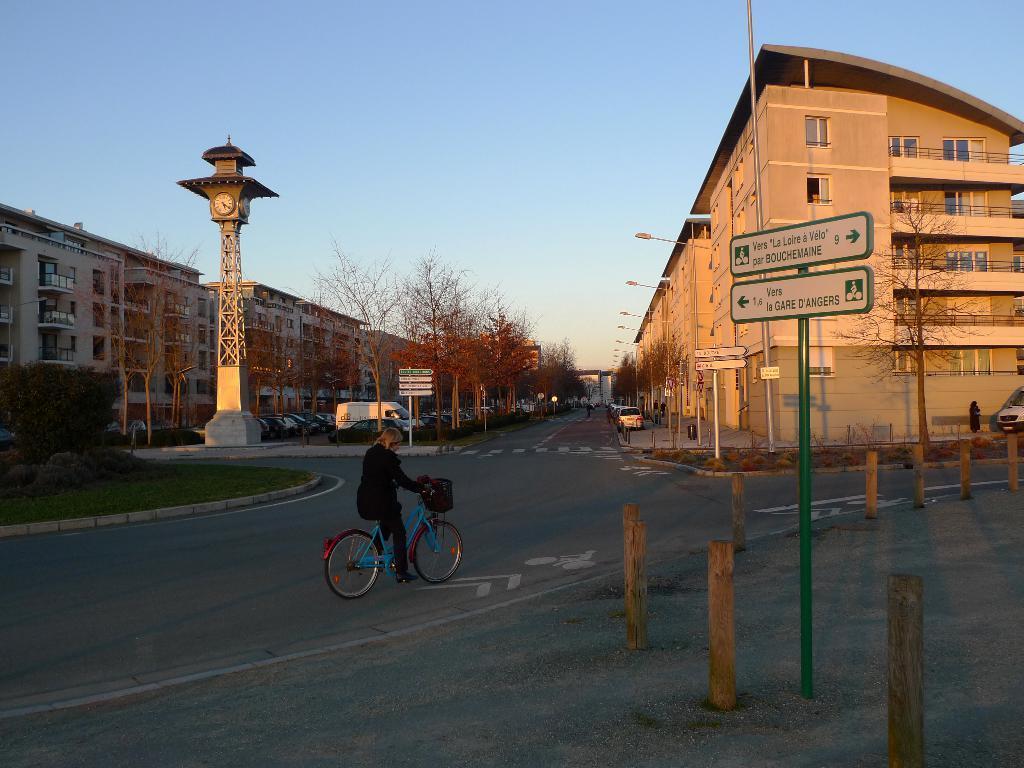Can you describe this image briefly? In this image there is a woman cycling on the road. In the left and in the right there are many buildings and also trees. Cars are also parked on the road. There is a clock tower visible in this image. There is a text board pole and also few poles present on the road. Sky is at the top. 